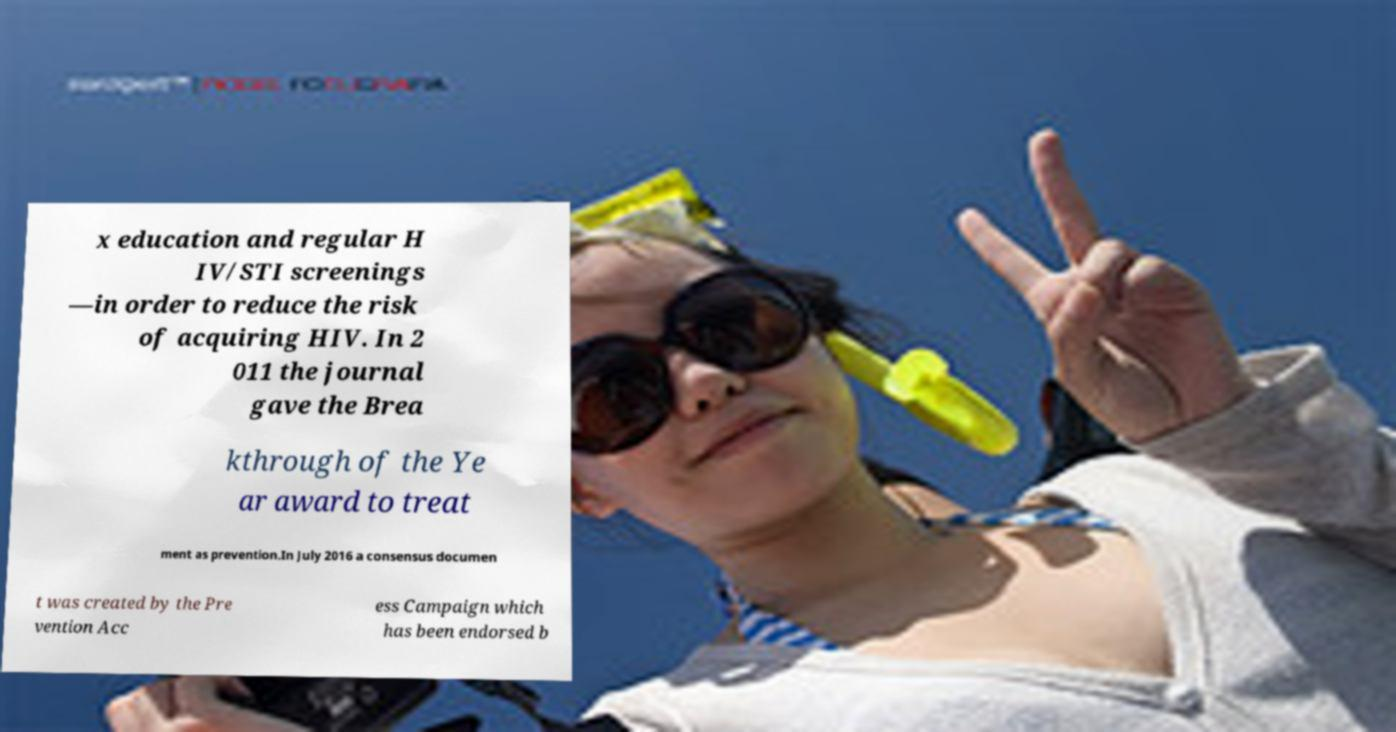Could you extract and type out the text from this image? x education and regular H IV/STI screenings —in order to reduce the risk of acquiring HIV. In 2 011 the journal gave the Brea kthrough of the Ye ar award to treat ment as prevention.In July 2016 a consensus documen t was created by the Pre vention Acc ess Campaign which has been endorsed b 